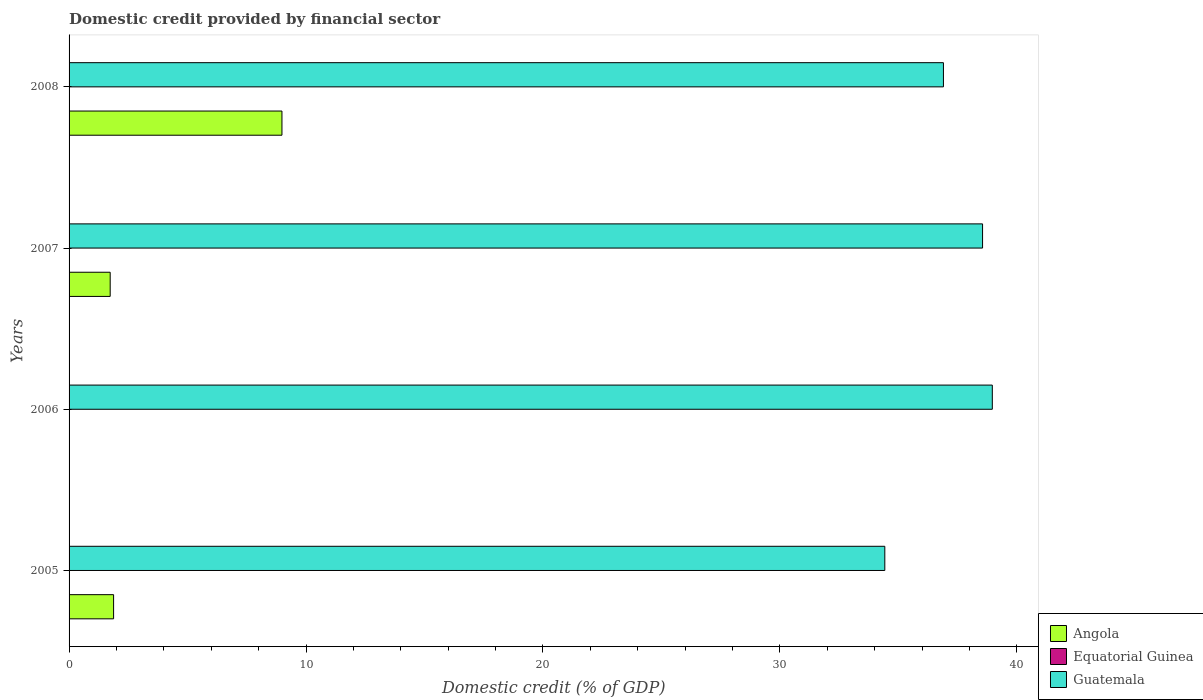How many different coloured bars are there?
Your answer should be compact. 2. Are the number of bars per tick equal to the number of legend labels?
Ensure brevity in your answer.  No. Are the number of bars on each tick of the Y-axis equal?
Offer a very short reply. No. How many bars are there on the 1st tick from the top?
Keep it short and to the point. 2. What is the label of the 3rd group of bars from the top?
Give a very brief answer. 2006. In how many cases, is the number of bars for a given year not equal to the number of legend labels?
Provide a succinct answer. 4. What is the domestic credit in Angola in 2005?
Make the answer very short. 1.88. Across all years, what is the maximum domestic credit in Guatemala?
Ensure brevity in your answer.  38.96. Across all years, what is the minimum domestic credit in Guatemala?
Make the answer very short. 34.43. In which year was the domestic credit in Angola maximum?
Provide a short and direct response. 2008. What is the total domestic credit in Guatemala in the graph?
Ensure brevity in your answer.  148.84. What is the difference between the domestic credit in Guatemala in 2005 and that in 2008?
Your answer should be compact. -2.47. What is the difference between the domestic credit in Equatorial Guinea in 2005 and the domestic credit in Guatemala in 2008?
Offer a very short reply. -36.9. In the year 2005, what is the difference between the domestic credit in Angola and domestic credit in Guatemala?
Your answer should be compact. -32.55. What is the ratio of the domestic credit in Angola in 2007 to that in 2008?
Keep it short and to the point. 0.19. What is the difference between the highest and the second highest domestic credit in Angola?
Give a very brief answer. 7.11. What is the difference between the highest and the lowest domestic credit in Angola?
Offer a terse response. 8.98. In how many years, is the domestic credit in Equatorial Guinea greater than the average domestic credit in Equatorial Guinea taken over all years?
Give a very brief answer. 0. Is it the case that in every year, the sum of the domestic credit in Guatemala and domestic credit in Equatorial Guinea is greater than the domestic credit in Angola?
Keep it short and to the point. Yes. What is the difference between two consecutive major ticks on the X-axis?
Your answer should be very brief. 10. Are the values on the major ticks of X-axis written in scientific E-notation?
Your answer should be very brief. No. Does the graph contain grids?
Provide a succinct answer. No. Where does the legend appear in the graph?
Give a very brief answer. Bottom right. What is the title of the graph?
Your response must be concise. Domestic credit provided by financial sector. Does "Uruguay" appear as one of the legend labels in the graph?
Offer a very short reply. No. What is the label or title of the X-axis?
Make the answer very short. Domestic credit (% of GDP). What is the Domestic credit (% of GDP) in Angola in 2005?
Offer a terse response. 1.88. What is the Domestic credit (% of GDP) in Equatorial Guinea in 2005?
Ensure brevity in your answer.  0. What is the Domestic credit (% of GDP) in Guatemala in 2005?
Offer a very short reply. 34.43. What is the Domestic credit (% of GDP) in Angola in 2006?
Provide a succinct answer. 0. What is the Domestic credit (% of GDP) of Guatemala in 2006?
Keep it short and to the point. 38.96. What is the Domestic credit (% of GDP) of Angola in 2007?
Keep it short and to the point. 1.74. What is the Domestic credit (% of GDP) in Equatorial Guinea in 2007?
Provide a short and direct response. 0. What is the Domestic credit (% of GDP) of Guatemala in 2007?
Give a very brief answer. 38.55. What is the Domestic credit (% of GDP) in Angola in 2008?
Your answer should be compact. 8.98. What is the Domestic credit (% of GDP) in Guatemala in 2008?
Your answer should be very brief. 36.9. Across all years, what is the maximum Domestic credit (% of GDP) of Angola?
Offer a very short reply. 8.98. Across all years, what is the maximum Domestic credit (% of GDP) in Guatemala?
Your answer should be very brief. 38.96. Across all years, what is the minimum Domestic credit (% of GDP) in Guatemala?
Provide a short and direct response. 34.43. What is the total Domestic credit (% of GDP) of Angola in the graph?
Your answer should be very brief. 12.6. What is the total Domestic credit (% of GDP) of Equatorial Guinea in the graph?
Provide a short and direct response. 0. What is the total Domestic credit (% of GDP) in Guatemala in the graph?
Make the answer very short. 148.84. What is the difference between the Domestic credit (% of GDP) of Guatemala in 2005 and that in 2006?
Give a very brief answer. -4.54. What is the difference between the Domestic credit (% of GDP) of Angola in 2005 and that in 2007?
Offer a very short reply. 0.14. What is the difference between the Domestic credit (% of GDP) in Guatemala in 2005 and that in 2007?
Provide a succinct answer. -4.13. What is the difference between the Domestic credit (% of GDP) of Angola in 2005 and that in 2008?
Keep it short and to the point. -7.11. What is the difference between the Domestic credit (% of GDP) of Guatemala in 2005 and that in 2008?
Provide a succinct answer. -2.47. What is the difference between the Domestic credit (% of GDP) in Guatemala in 2006 and that in 2007?
Provide a succinct answer. 0.41. What is the difference between the Domestic credit (% of GDP) in Guatemala in 2006 and that in 2008?
Ensure brevity in your answer.  2.06. What is the difference between the Domestic credit (% of GDP) of Angola in 2007 and that in 2008?
Ensure brevity in your answer.  -7.25. What is the difference between the Domestic credit (% of GDP) of Guatemala in 2007 and that in 2008?
Your response must be concise. 1.65. What is the difference between the Domestic credit (% of GDP) in Angola in 2005 and the Domestic credit (% of GDP) in Guatemala in 2006?
Keep it short and to the point. -37.08. What is the difference between the Domestic credit (% of GDP) of Angola in 2005 and the Domestic credit (% of GDP) of Guatemala in 2007?
Give a very brief answer. -36.67. What is the difference between the Domestic credit (% of GDP) in Angola in 2005 and the Domestic credit (% of GDP) in Guatemala in 2008?
Provide a short and direct response. -35.02. What is the difference between the Domestic credit (% of GDP) of Angola in 2007 and the Domestic credit (% of GDP) of Guatemala in 2008?
Make the answer very short. -35.17. What is the average Domestic credit (% of GDP) in Angola per year?
Ensure brevity in your answer.  3.15. What is the average Domestic credit (% of GDP) of Guatemala per year?
Provide a succinct answer. 37.21. In the year 2005, what is the difference between the Domestic credit (% of GDP) of Angola and Domestic credit (% of GDP) of Guatemala?
Offer a very short reply. -32.55. In the year 2007, what is the difference between the Domestic credit (% of GDP) of Angola and Domestic credit (% of GDP) of Guatemala?
Provide a succinct answer. -36.82. In the year 2008, what is the difference between the Domestic credit (% of GDP) in Angola and Domestic credit (% of GDP) in Guatemala?
Your answer should be compact. -27.92. What is the ratio of the Domestic credit (% of GDP) of Guatemala in 2005 to that in 2006?
Offer a terse response. 0.88. What is the ratio of the Domestic credit (% of GDP) in Angola in 2005 to that in 2007?
Keep it short and to the point. 1.08. What is the ratio of the Domestic credit (% of GDP) of Guatemala in 2005 to that in 2007?
Make the answer very short. 0.89. What is the ratio of the Domestic credit (% of GDP) of Angola in 2005 to that in 2008?
Your answer should be very brief. 0.21. What is the ratio of the Domestic credit (% of GDP) of Guatemala in 2005 to that in 2008?
Keep it short and to the point. 0.93. What is the ratio of the Domestic credit (% of GDP) in Guatemala in 2006 to that in 2007?
Keep it short and to the point. 1.01. What is the ratio of the Domestic credit (% of GDP) of Guatemala in 2006 to that in 2008?
Your response must be concise. 1.06. What is the ratio of the Domestic credit (% of GDP) of Angola in 2007 to that in 2008?
Your response must be concise. 0.19. What is the ratio of the Domestic credit (% of GDP) in Guatemala in 2007 to that in 2008?
Provide a short and direct response. 1.04. What is the difference between the highest and the second highest Domestic credit (% of GDP) of Angola?
Make the answer very short. 7.11. What is the difference between the highest and the second highest Domestic credit (% of GDP) in Guatemala?
Your answer should be compact. 0.41. What is the difference between the highest and the lowest Domestic credit (% of GDP) in Angola?
Offer a terse response. 8.98. What is the difference between the highest and the lowest Domestic credit (% of GDP) of Guatemala?
Your answer should be very brief. 4.54. 